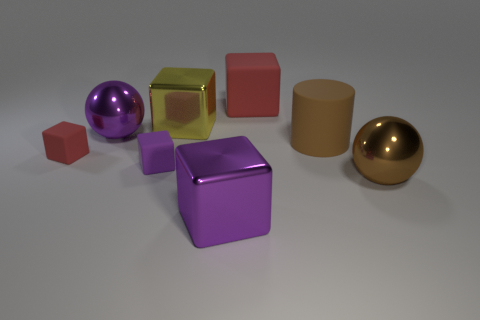What number of rubber things are either tiny cubes or red objects?
Provide a succinct answer. 3. Is there anything else that is the same size as the brown sphere?
Your answer should be compact. Yes. The large thing that is the same material as the brown cylinder is what color?
Your response must be concise. Red. How many spheres are either red things or large matte things?
Your response must be concise. 0. What number of things are small things or large purple metallic objects on the left side of the big purple metallic block?
Keep it short and to the point. 3. Are any tiny cyan blocks visible?
Provide a succinct answer. No. What number of rubber cylinders are the same color as the large matte block?
Give a very brief answer. 0. What material is the large thing that is the same color as the large cylinder?
Make the answer very short. Metal. There is a object to the right of the brown thing to the left of the brown metal object; what is its size?
Make the answer very short. Large. Are there any large blue cylinders that have the same material as the brown ball?
Offer a very short reply. No. 